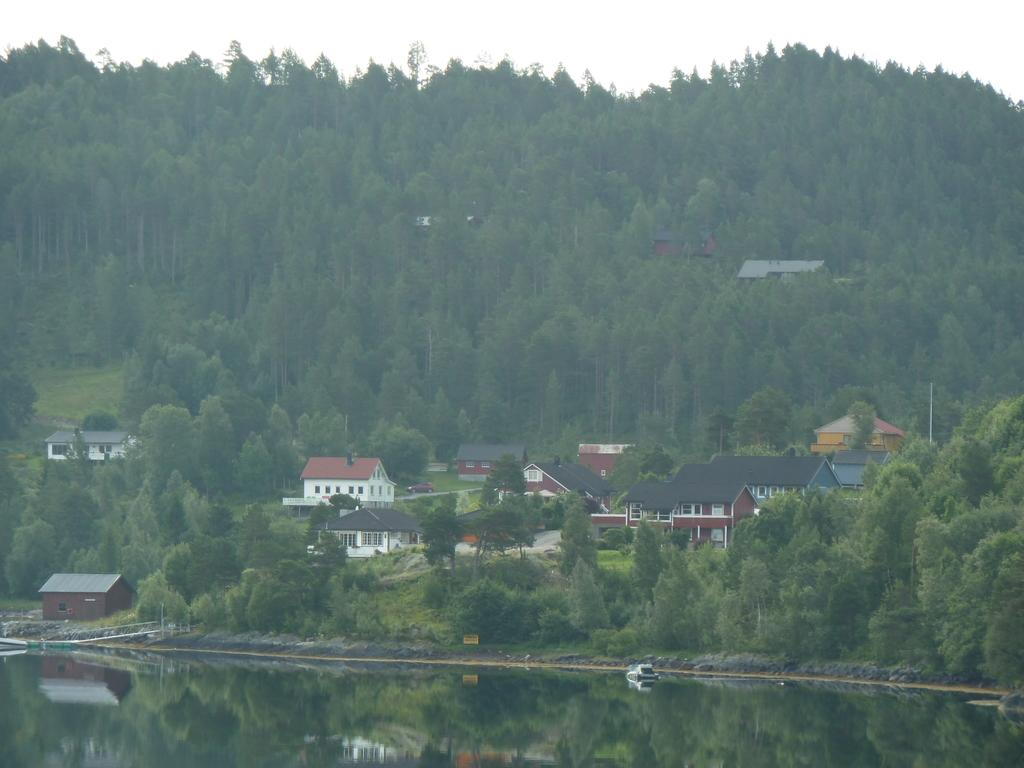What is the main subject of the image? There is a ship in the water in the image. What can be seen in the background of the image? There are trees, buildings, and the sky visible in the background of the image. Can you see any snails on the ship in the image? There are no snails visible on the ship in the image. Are there any women kissing on the ship in the image? There are no women or any kissing depicted on the ship in the image. 